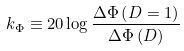<formula> <loc_0><loc_0><loc_500><loc_500>k _ { \Phi } \equiv 2 0 \log \frac { \Delta \Phi \left ( D = 1 \right ) } { \Delta \Phi \left ( D \right ) }</formula> 